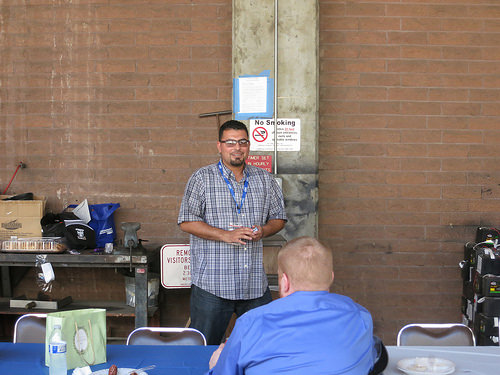<image>
Is there a press next to the teacher? Yes. The press is positioned adjacent to the teacher, located nearby in the same general area. 